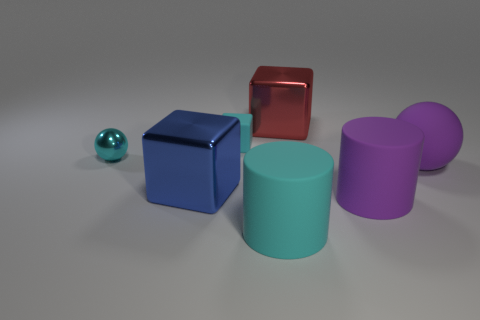Subtract all purple spheres. Subtract all yellow blocks. How many spheres are left? 1 Add 1 large yellow blocks. How many objects exist? 8 Subtract all balls. How many objects are left? 5 Subtract all rubber things. Subtract all red objects. How many objects are left? 2 Add 2 small matte things. How many small matte things are left? 3 Add 4 large cubes. How many large cubes exist? 6 Subtract 0 yellow spheres. How many objects are left? 7 